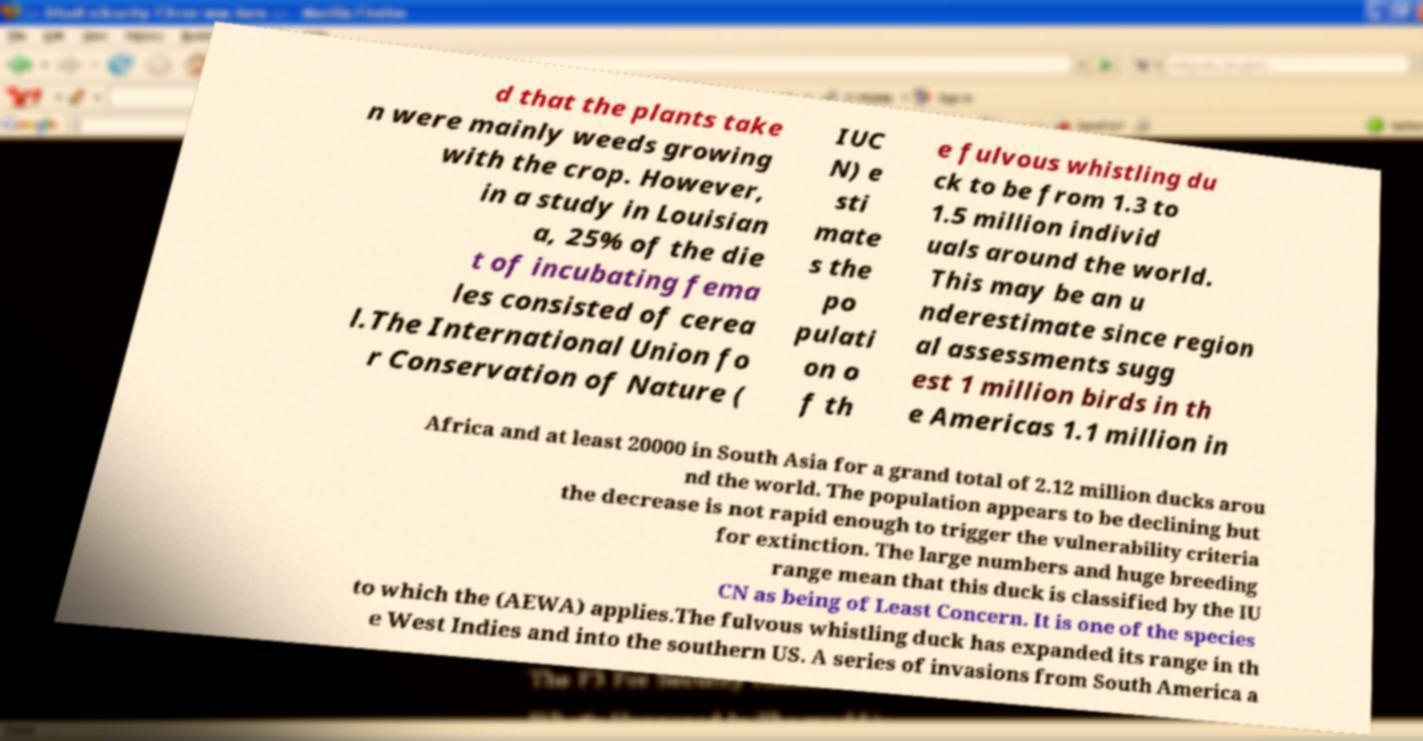Please read and relay the text visible in this image. What does it say? d that the plants take n were mainly weeds growing with the crop. However, in a study in Louisian a, 25% of the die t of incubating fema les consisted of cerea l.The International Union fo r Conservation of Nature ( IUC N) e sti mate s the po pulati on o f th e fulvous whistling du ck to be from 1.3 to 1.5 million individ uals around the world. This may be an u nderestimate since region al assessments sugg est 1 million birds in th e Americas 1.1 million in Africa and at least 20000 in South Asia for a grand total of 2.12 million ducks arou nd the world. The population appears to be declining but the decrease is not rapid enough to trigger the vulnerability criteria for extinction. The large numbers and huge breeding range mean that this duck is classified by the IU CN as being of Least Concern. It is one of the species to which the (AEWA) applies.The fulvous whistling duck has expanded its range in th e West Indies and into the southern US. A series of invasions from South America a 